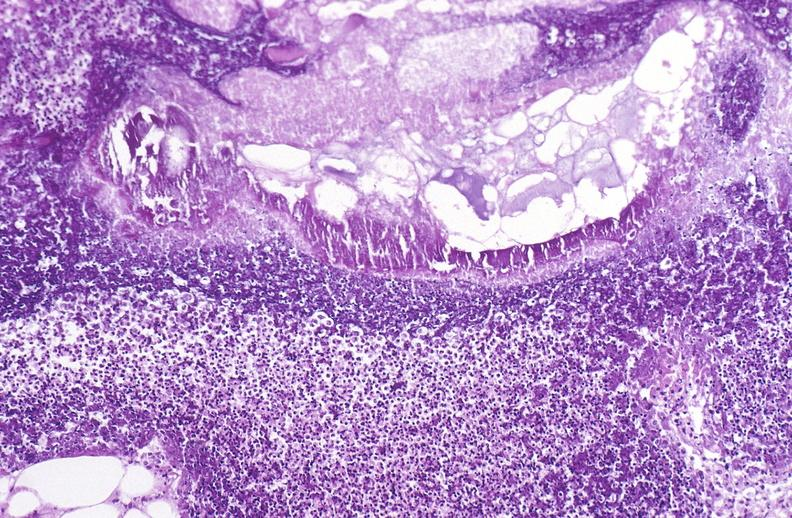where is this?
Answer the question using a single word or phrase. Pancreas 